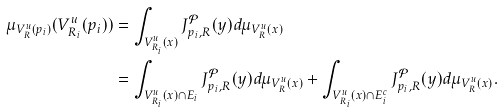<formula> <loc_0><loc_0><loc_500><loc_500>\mu _ { V ^ { u } _ { R } ( p _ { i } ) } ( V ^ { u } _ { R _ { i } } ( p _ { i } ) ) & = \int _ { V ^ { u } _ { R _ { i } } ( x ) } J _ { p _ { i } , R } ^ { \mathcal { P } } ( y ) d \mu _ { V ^ { u } _ { R } ( x ) } \\ & = \int _ { V ^ { u } _ { R _ { i } } ( x ) \cap E _ { i } } J _ { p _ { i } , R } ^ { \mathcal { P } } ( y ) d \mu _ { V ^ { u } _ { R } ( x ) } + \int _ { V ^ { u } _ { R _ { i } } ( x ) \cap E _ { i } ^ { c } } J _ { p _ { i } , R } ^ { \mathcal { P } } ( y ) d \mu _ { V ^ { u } _ { R } ( x ) } .</formula> 